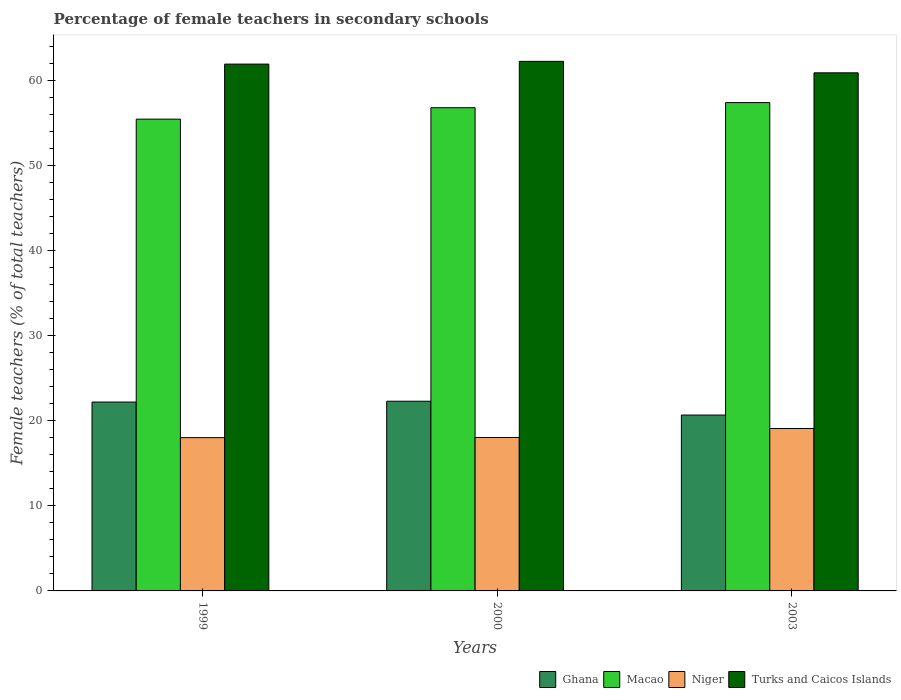How many different coloured bars are there?
Make the answer very short. 4. How many groups of bars are there?
Offer a very short reply. 3. Are the number of bars per tick equal to the number of legend labels?
Offer a very short reply. Yes. How many bars are there on the 3rd tick from the left?
Provide a succinct answer. 4. How many bars are there on the 1st tick from the right?
Offer a terse response. 4. What is the label of the 3rd group of bars from the left?
Your answer should be very brief. 2003. What is the percentage of female teachers in Macao in 1999?
Your answer should be compact. 55.51. Across all years, what is the maximum percentage of female teachers in Macao?
Provide a short and direct response. 57.45. Across all years, what is the minimum percentage of female teachers in Niger?
Keep it short and to the point. 18.03. In which year was the percentage of female teachers in Niger maximum?
Keep it short and to the point. 2003. What is the total percentage of female teachers in Macao in the graph?
Your answer should be very brief. 169.81. What is the difference between the percentage of female teachers in Ghana in 1999 and that in 2000?
Your answer should be compact. -0.1. What is the difference between the percentage of female teachers in Turks and Caicos Islands in 2000 and the percentage of female teachers in Ghana in 2003?
Your answer should be very brief. 41.61. What is the average percentage of female teachers in Ghana per year?
Make the answer very short. 21.75. In the year 2000, what is the difference between the percentage of female teachers in Turks and Caicos Islands and percentage of female teachers in Ghana?
Make the answer very short. 39.99. What is the ratio of the percentage of female teachers in Niger in 1999 to that in 2000?
Provide a succinct answer. 1. Is the percentage of female teachers in Macao in 1999 less than that in 2000?
Provide a succinct answer. Yes. What is the difference between the highest and the second highest percentage of female teachers in Macao?
Offer a terse response. 0.6. What is the difference between the highest and the lowest percentage of female teachers in Ghana?
Give a very brief answer. 1.62. What does the 2nd bar from the right in 2003 represents?
Offer a terse response. Niger. Is it the case that in every year, the sum of the percentage of female teachers in Ghana and percentage of female teachers in Macao is greater than the percentage of female teachers in Niger?
Ensure brevity in your answer.  Yes. How many bars are there?
Ensure brevity in your answer.  12. Are all the bars in the graph horizontal?
Your answer should be compact. No. How many years are there in the graph?
Offer a very short reply. 3. Does the graph contain any zero values?
Provide a succinct answer. No. Where does the legend appear in the graph?
Give a very brief answer. Bottom right. How are the legend labels stacked?
Offer a very short reply. Horizontal. What is the title of the graph?
Give a very brief answer. Percentage of female teachers in secondary schools. Does "Algeria" appear as one of the legend labels in the graph?
Make the answer very short. No. What is the label or title of the X-axis?
Give a very brief answer. Years. What is the label or title of the Y-axis?
Make the answer very short. Female teachers (% of total teachers). What is the Female teachers (% of total teachers) of Ghana in 1999?
Provide a succinct answer. 22.22. What is the Female teachers (% of total teachers) of Macao in 1999?
Make the answer very short. 55.51. What is the Female teachers (% of total teachers) in Niger in 1999?
Your response must be concise. 18.03. What is the Female teachers (% of total teachers) of Turks and Caicos Islands in 1999?
Provide a succinct answer. 61.98. What is the Female teachers (% of total teachers) in Ghana in 2000?
Give a very brief answer. 22.32. What is the Female teachers (% of total teachers) in Macao in 2000?
Make the answer very short. 56.85. What is the Female teachers (% of total teachers) of Niger in 2000?
Offer a terse response. 18.05. What is the Female teachers (% of total teachers) of Turks and Caicos Islands in 2000?
Keep it short and to the point. 62.31. What is the Female teachers (% of total teachers) in Ghana in 2003?
Make the answer very short. 20.69. What is the Female teachers (% of total teachers) in Macao in 2003?
Offer a very short reply. 57.45. What is the Female teachers (% of total teachers) in Niger in 2003?
Your answer should be compact. 19.11. What is the Female teachers (% of total teachers) in Turks and Caicos Islands in 2003?
Your response must be concise. 60.96. Across all years, what is the maximum Female teachers (% of total teachers) in Ghana?
Your answer should be compact. 22.32. Across all years, what is the maximum Female teachers (% of total teachers) of Macao?
Offer a terse response. 57.45. Across all years, what is the maximum Female teachers (% of total teachers) in Niger?
Your response must be concise. 19.11. Across all years, what is the maximum Female teachers (% of total teachers) in Turks and Caicos Islands?
Provide a succinct answer. 62.31. Across all years, what is the minimum Female teachers (% of total teachers) of Ghana?
Give a very brief answer. 20.69. Across all years, what is the minimum Female teachers (% of total teachers) of Macao?
Your answer should be compact. 55.51. Across all years, what is the minimum Female teachers (% of total teachers) in Niger?
Your answer should be very brief. 18.03. Across all years, what is the minimum Female teachers (% of total teachers) in Turks and Caicos Islands?
Make the answer very short. 60.96. What is the total Female teachers (% of total teachers) of Ghana in the graph?
Your answer should be very brief. 65.24. What is the total Female teachers (% of total teachers) of Macao in the graph?
Offer a very short reply. 169.81. What is the total Female teachers (% of total teachers) of Niger in the graph?
Make the answer very short. 55.2. What is the total Female teachers (% of total teachers) of Turks and Caicos Islands in the graph?
Ensure brevity in your answer.  185.25. What is the difference between the Female teachers (% of total teachers) of Ghana in 1999 and that in 2000?
Provide a short and direct response. -0.1. What is the difference between the Female teachers (% of total teachers) of Macao in 1999 and that in 2000?
Your answer should be compact. -1.35. What is the difference between the Female teachers (% of total teachers) in Niger in 1999 and that in 2000?
Offer a terse response. -0.02. What is the difference between the Female teachers (% of total teachers) of Turks and Caicos Islands in 1999 and that in 2000?
Give a very brief answer. -0.32. What is the difference between the Female teachers (% of total teachers) in Ghana in 1999 and that in 2003?
Make the answer very short. 1.53. What is the difference between the Female teachers (% of total teachers) in Macao in 1999 and that in 2003?
Provide a short and direct response. -1.95. What is the difference between the Female teachers (% of total teachers) in Niger in 1999 and that in 2003?
Provide a short and direct response. -1.08. What is the difference between the Female teachers (% of total teachers) of Turks and Caicos Islands in 1999 and that in 2003?
Give a very brief answer. 1.02. What is the difference between the Female teachers (% of total teachers) of Ghana in 2000 and that in 2003?
Ensure brevity in your answer.  1.62. What is the difference between the Female teachers (% of total teachers) of Macao in 2000 and that in 2003?
Make the answer very short. -0.6. What is the difference between the Female teachers (% of total teachers) of Niger in 2000 and that in 2003?
Your answer should be very brief. -1.06. What is the difference between the Female teachers (% of total teachers) of Turks and Caicos Islands in 2000 and that in 2003?
Ensure brevity in your answer.  1.35. What is the difference between the Female teachers (% of total teachers) in Ghana in 1999 and the Female teachers (% of total teachers) in Macao in 2000?
Offer a very short reply. -34.63. What is the difference between the Female teachers (% of total teachers) of Ghana in 1999 and the Female teachers (% of total teachers) of Niger in 2000?
Offer a terse response. 4.17. What is the difference between the Female teachers (% of total teachers) of Ghana in 1999 and the Female teachers (% of total teachers) of Turks and Caicos Islands in 2000?
Your answer should be very brief. -40.09. What is the difference between the Female teachers (% of total teachers) of Macao in 1999 and the Female teachers (% of total teachers) of Niger in 2000?
Ensure brevity in your answer.  37.46. What is the difference between the Female teachers (% of total teachers) of Macao in 1999 and the Female teachers (% of total teachers) of Turks and Caicos Islands in 2000?
Provide a short and direct response. -6.8. What is the difference between the Female teachers (% of total teachers) of Niger in 1999 and the Female teachers (% of total teachers) of Turks and Caicos Islands in 2000?
Keep it short and to the point. -44.27. What is the difference between the Female teachers (% of total teachers) in Ghana in 1999 and the Female teachers (% of total teachers) in Macao in 2003?
Ensure brevity in your answer.  -35.23. What is the difference between the Female teachers (% of total teachers) of Ghana in 1999 and the Female teachers (% of total teachers) of Niger in 2003?
Make the answer very short. 3.11. What is the difference between the Female teachers (% of total teachers) in Ghana in 1999 and the Female teachers (% of total teachers) in Turks and Caicos Islands in 2003?
Your answer should be very brief. -38.74. What is the difference between the Female teachers (% of total teachers) in Macao in 1999 and the Female teachers (% of total teachers) in Niger in 2003?
Provide a succinct answer. 36.4. What is the difference between the Female teachers (% of total teachers) of Macao in 1999 and the Female teachers (% of total teachers) of Turks and Caicos Islands in 2003?
Your answer should be compact. -5.45. What is the difference between the Female teachers (% of total teachers) of Niger in 1999 and the Female teachers (% of total teachers) of Turks and Caicos Islands in 2003?
Your answer should be very brief. -42.92. What is the difference between the Female teachers (% of total teachers) of Ghana in 2000 and the Female teachers (% of total teachers) of Macao in 2003?
Offer a terse response. -35.13. What is the difference between the Female teachers (% of total teachers) in Ghana in 2000 and the Female teachers (% of total teachers) in Niger in 2003?
Your response must be concise. 3.21. What is the difference between the Female teachers (% of total teachers) of Ghana in 2000 and the Female teachers (% of total teachers) of Turks and Caicos Islands in 2003?
Provide a succinct answer. -38.64. What is the difference between the Female teachers (% of total teachers) of Macao in 2000 and the Female teachers (% of total teachers) of Niger in 2003?
Make the answer very short. 37.74. What is the difference between the Female teachers (% of total teachers) of Macao in 2000 and the Female teachers (% of total teachers) of Turks and Caicos Islands in 2003?
Your answer should be compact. -4.11. What is the difference between the Female teachers (% of total teachers) in Niger in 2000 and the Female teachers (% of total teachers) in Turks and Caicos Islands in 2003?
Your answer should be very brief. -42.91. What is the average Female teachers (% of total teachers) of Ghana per year?
Offer a terse response. 21.75. What is the average Female teachers (% of total teachers) in Macao per year?
Your answer should be very brief. 56.6. What is the average Female teachers (% of total teachers) in Niger per year?
Provide a succinct answer. 18.4. What is the average Female teachers (% of total teachers) in Turks and Caicos Islands per year?
Provide a short and direct response. 61.75. In the year 1999, what is the difference between the Female teachers (% of total teachers) of Ghana and Female teachers (% of total teachers) of Macao?
Make the answer very short. -33.28. In the year 1999, what is the difference between the Female teachers (% of total teachers) in Ghana and Female teachers (% of total teachers) in Niger?
Make the answer very short. 4.19. In the year 1999, what is the difference between the Female teachers (% of total teachers) of Ghana and Female teachers (% of total teachers) of Turks and Caicos Islands?
Your answer should be very brief. -39.76. In the year 1999, what is the difference between the Female teachers (% of total teachers) in Macao and Female teachers (% of total teachers) in Niger?
Offer a terse response. 37.47. In the year 1999, what is the difference between the Female teachers (% of total teachers) in Macao and Female teachers (% of total teachers) in Turks and Caicos Islands?
Ensure brevity in your answer.  -6.48. In the year 1999, what is the difference between the Female teachers (% of total teachers) of Niger and Female teachers (% of total teachers) of Turks and Caicos Islands?
Provide a succinct answer. -43.95. In the year 2000, what is the difference between the Female teachers (% of total teachers) in Ghana and Female teachers (% of total teachers) in Macao?
Provide a succinct answer. -34.53. In the year 2000, what is the difference between the Female teachers (% of total teachers) of Ghana and Female teachers (% of total teachers) of Niger?
Offer a terse response. 4.27. In the year 2000, what is the difference between the Female teachers (% of total teachers) in Ghana and Female teachers (% of total teachers) in Turks and Caicos Islands?
Your answer should be compact. -39.99. In the year 2000, what is the difference between the Female teachers (% of total teachers) of Macao and Female teachers (% of total teachers) of Niger?
Ensure brevity in your answer.  38.8. In the year 2000, what is the difference between the Female teachers (% of total teachers) in Macao and Female teachers (% of total teachers) in Turks and Caicos Islands?
Offer a terse response. -5.45. In the year 2000, what is the difference between the Female teachers (% of total teachers) of Niger and Female teachers (% of total teachers) of Turks and Caicos Islands?
Give a very brief answer. -44.26. In the year 2003, what is the difference between the Female teachers (% of total teachers) in Ghana and Female teachers (% of total teachers) in Macao?
Give a very brief answer. -36.76. In the year 2003, what is the difference between the Female teachers (% of total teachers) in Ghana and Female teachers (% of total teachers) in Niger?
Your answer should be compact. 1.58. In the year 2003, what is the difference between the Female teachers (% of total teachers) of Ghana and Female teachers (% of total teachers) of Turks and Caicos Islands?
Ensure brevity in your answer.  -40.26. In the year 2003, what is the difference between the Female teachers (% of total teachers) of Macao and Female teachers (% of total teachers) of Niger?
Offer a very short reply. 38.34. In the year 2003, what is the difference between the Female teachers (% of total teachers) of Macao and Female teachers (% of total teachers) of Turks and Caicos Islands?
Your answer should be compact. -3.5. In the year 2003, what is the difference between the Female teachers (% of total teachers) in Niger and Female teachers (% of total teachers) in Turks and Caicos Islands?
Offer a terse response. -41.85. What is the ratio of the Female teachers (% of total teachers) of Ghana in 1999 to that in 2000?
Your response must be concise. 1. What is the ratio of the Female teachers (% of total teachers) of Macao in 1999 to that in 2000?
Offer a very short reply. 0.98. What is the ratio of the Female teachers (% of total teachers) of Niger in 1999 to that in 2000?
Provide a short and direct response. 1. What is the ratio of the Female teachers (% of total teachers) of Turks and Caicos Islands in 1999 to that in 2000?
Keep it short and to the point. 0.99. What is the ratio of the Female teachers (% of total teachers) of Ghana in 1999 to that in 2003?
Your response must be concise. 1.07. What is the ratio of the Female teachers (% of total teachers) of Macao in 1999 to that in 2003?
Provide a short and direct response. 0.97. What is the ratio of the Female teachers (% of total teachers) in Niger in 1999 to that in 2003?
Your response must be concise. 0.94. What is the ratio of the Female teachers (% of total teachers) in Turks and Caicos Islands in 1999 to that in 2003?
Provide a succinct answer. 1.02. What is the ratio of the Female teachers (% of total teachers) of Ghana in 2000 to that in 2003?
Your answer should be compact. 1.08. What is the ratio of the Female teachers (% of total teachers) of Niger in 2000 to that in 2003?
Make the answer very short. 0.94. What is the ratio of the Female teachers (% of total teachers) of Turks and Caicos Islands in 2000 to that in 2003?
Offer a terse response. 1.02. What is the difference between the highest and the second highest Female teachers (% of total teachers) of Ghana?
Provide a succinct answer. 0.1. What is the difference between the highest and the second highest Female teachers (% of total teachers) in Macao?
Keep it short and to the point. 0.6. What is the difference between the highest and the second highest Female teachers (% of total teachers) in Niger?
Provide a succinct answer. 1.06. What is the difference between the highest and the second highest Female teachers (% of total teachers) in Turks and Caicos Islands?
Your response must be concise. 0.32. What is the difference between the highest and the lowest Female teachers (% of total teachers) of Ghana?
Ensure brevity in your answer.  1.62. What is the difference between the highest and the lowest Female teachers (% of total teachers) in Macao?
Your response must be concise. 1.95. What is the difference between the highest and the lowest Female teachers (% of total teachers) in Niger?
Offer a terse response. 1.08. What is the difference between the highest and the lowest Female teachers (% of total teachers) in Turks and Caicos Islands?
Your answer should be compact. 1.35. 